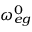Convert formula to latex. <formula><loc_0><loc_0><loc_500><loc_500>\omega _ { e g } ^ { 0 }</formula> 